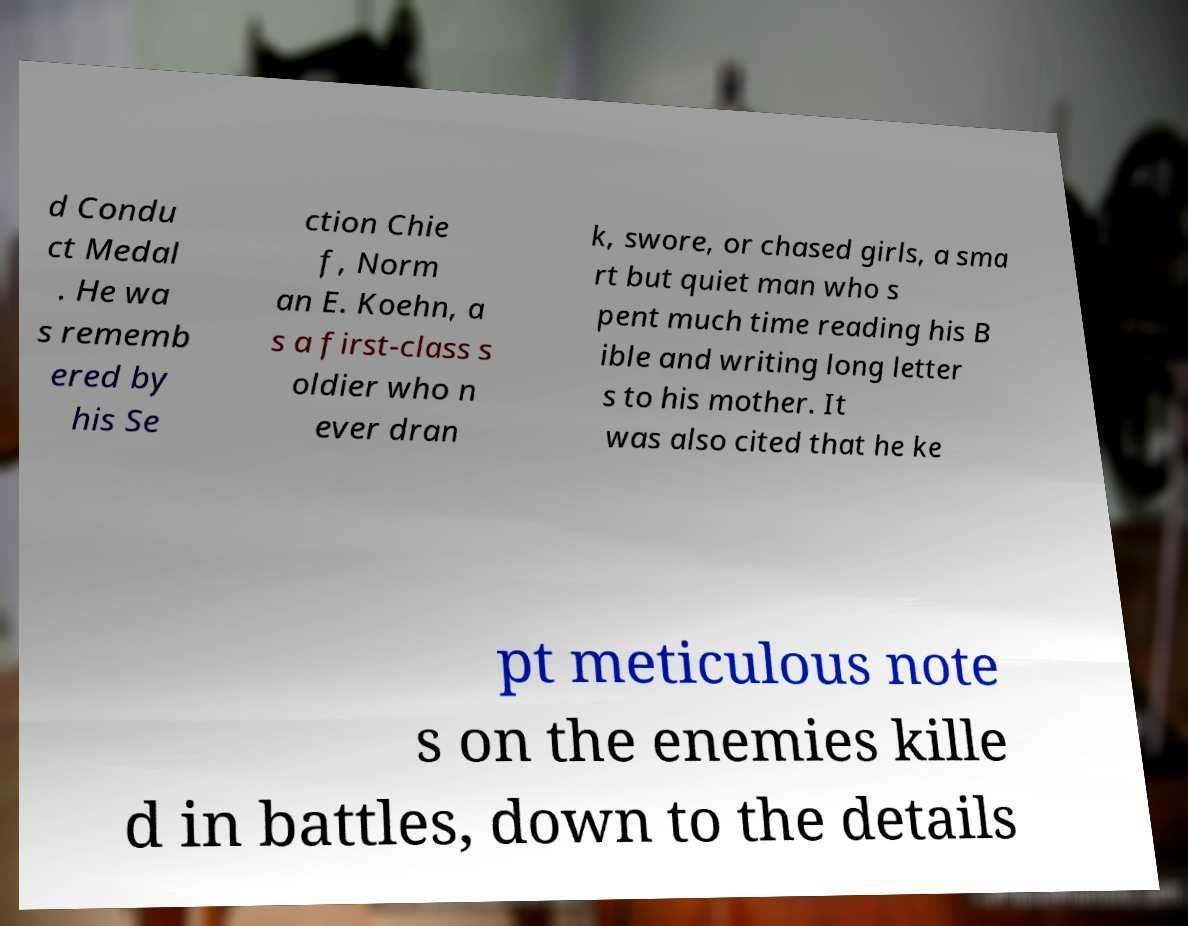There's text embedded in this image that I need extracted. Can you transcribe it verbatim? d Condu ct Medal . He wa s rememb ered by his Se ction Chie f, Norm an E. Koehn, a s a first-class s oldier who n ever dran k, swore, or chased girls, a sma rt but quiet man who s pent much time reading his B ible and writing long letter s to his mother. It was also cited that he ke pt meticulous note s on the enemies kille d in battles, down to the details 